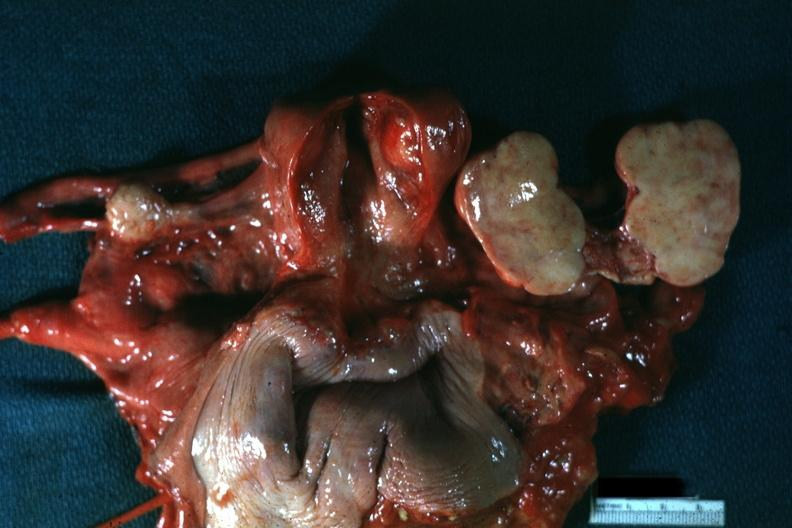s female reproductive present?
Answer the question using a single word or phrase. Yes 